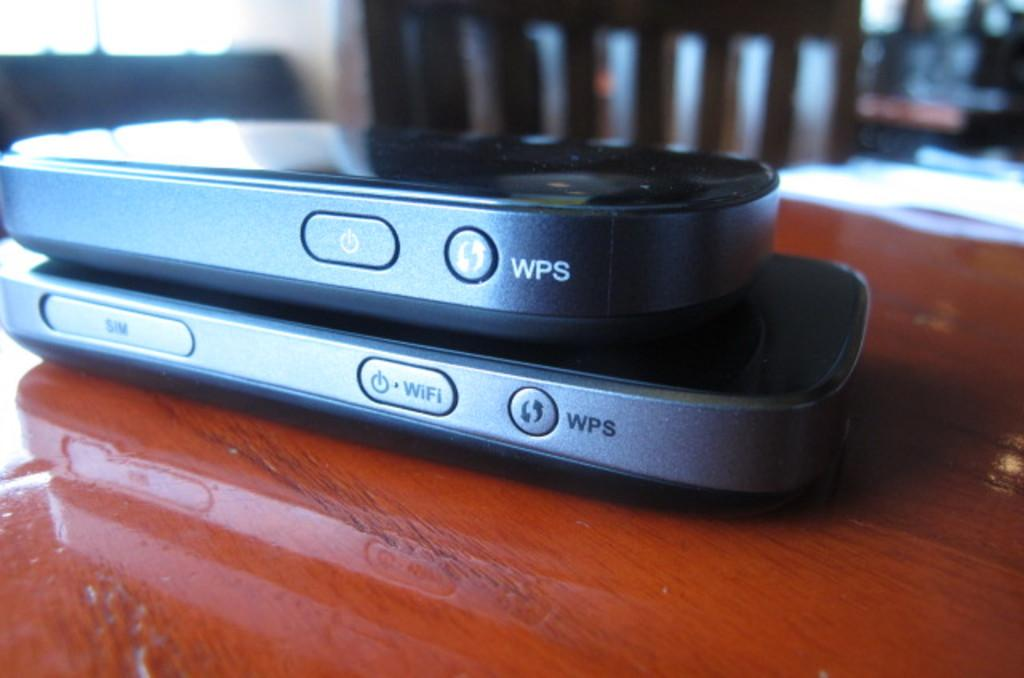What electronic devices are on the table in the image? There are mobile phones on the table in the image. What type of writing material is on the table? There is a paper on the table. Can you describe the background of the image? There is a chair in the background of the image. What type of blood is visible on the mobile phones in the image? There is no blood visible on the mobile phones in the image. Where is the market located in the image? There is no market present in the image. 